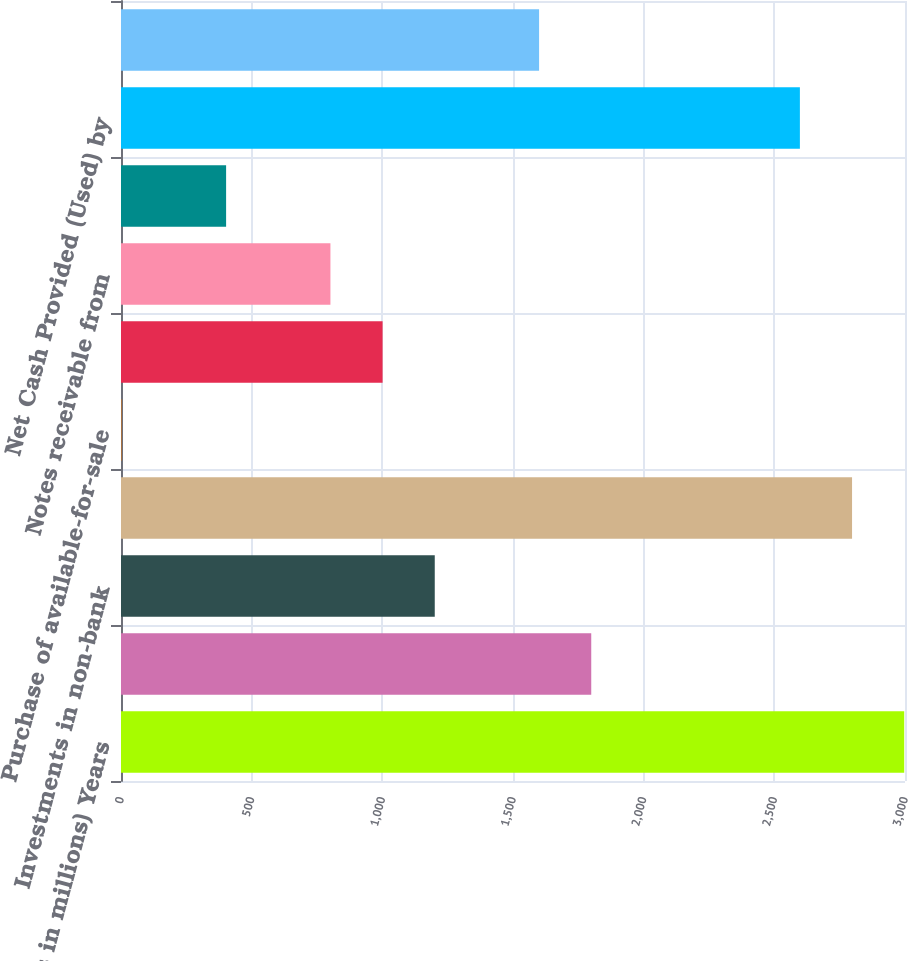Convert chart. <chart><loc_0><loc_0><loc_500><loc_500><bar_chart><fcel>(Dollars in millions) Years<fcel>Net Cash Provided by Operating<fcel>Investments in non-bank<fcel>Securities purchased under<fcel>Purchase of available-for-sale<fcel>Interest-bearing deposits with<fcel>Notes receivable from<fcel>Other<fcel>Net Cash Provided (Used) by<fcel>Net proceeds from commercial<nl><fcel>2997<fcel>1799.4<fcel>1200.6<fcel>2797.4<fcel>3<fcel>1001<fcel>801.4<fcel>402.2<fcel>2597.8<fcel>1599.8<nl></chart> 